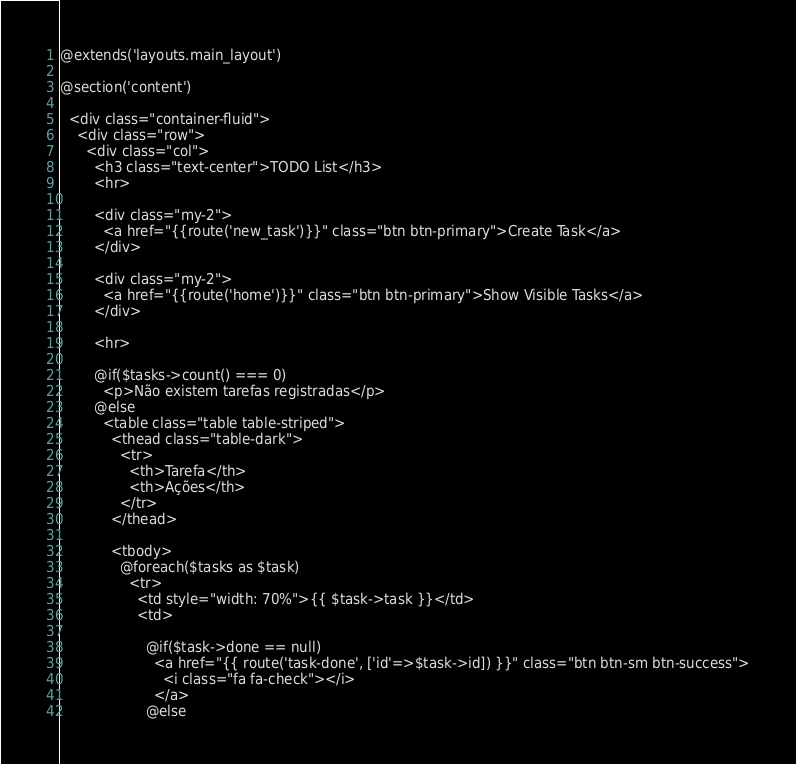<code> <loc_0><loc_0><loc_500><loc_500><_PHP_>@extends('layouts.main_layout')

@section('content')

  <div class="container-fluid">
    <div class="row">
      <div class="col">
        <h3 class="text-center">TODO List</h3>
        <hr>

        <div class="my-2">
          <a href="{{route('new_task')}}" class="btn btn-primary">Create Task</a>
        </div>

        <div class="my-2">
          <a href="{{route('home')}}" class="btn btn-primary">Show Visible Tasks</a>
        </div>

        <hr>

        @if($tasks->count() === 0)
          <p>Não existem tarefas registradas</p>
        @else 
          <table class="table table-striped">
            <thead class="table-dark">
              <tr>
                <th>Tarefa</th>
                <th>Ações</th>
              </tr>
            </thead>

            <tbody>
              @foreach($tasks as $task)
                <tr>
                  <td style="width: 70%">{{ $task->task }}</td>
                  <td>

                    @if($task->done == null)
                      <a href="{{ route('task-done', ['id'=>$task->id]) }}" class="btn btn-sm btn-success">
                        <i class="fa fa-check"></i>
                      </a>
                    @else</code> 